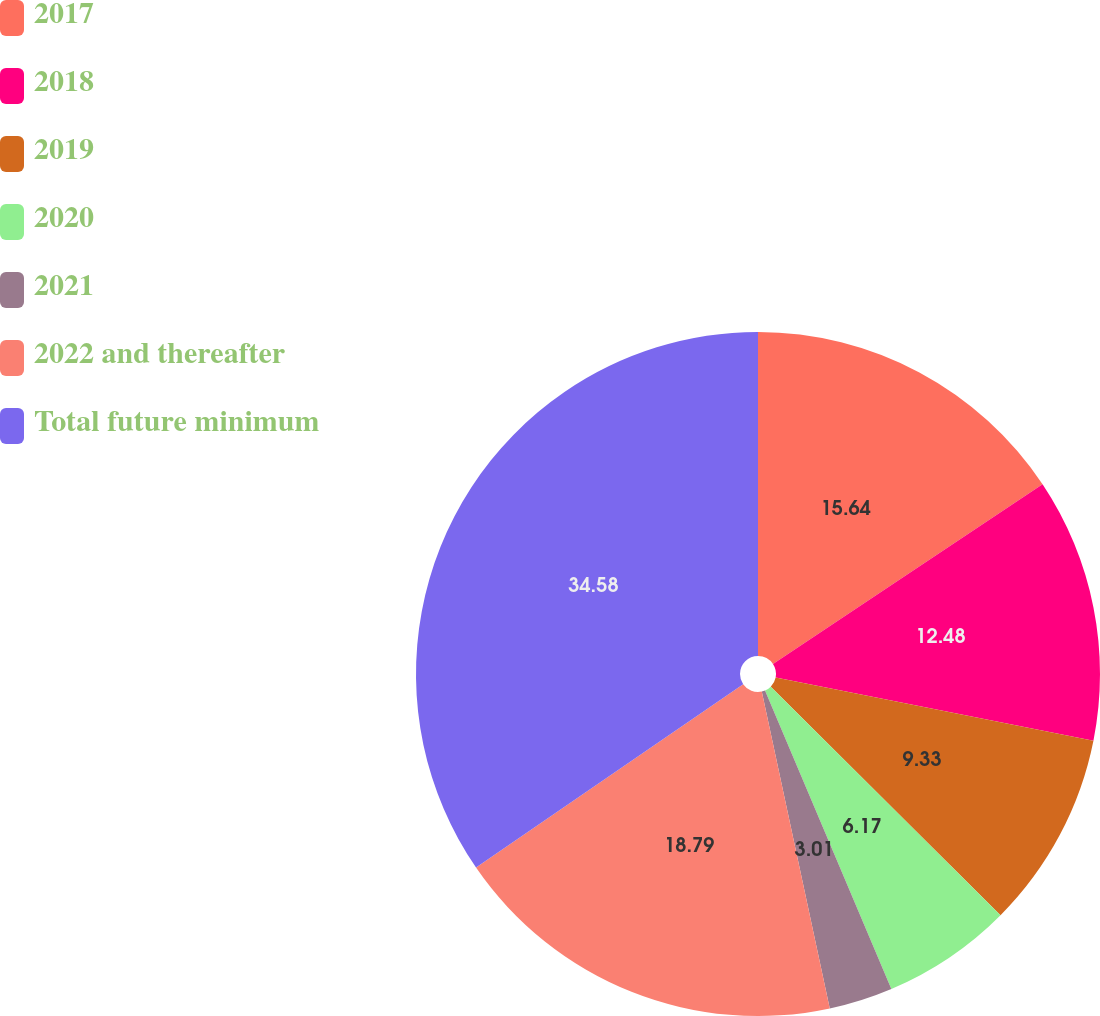<chart> <loc_0><loc_0><loc_500><loc_500><pie_chart><fcel>2017<fcel>2018<fcel>2019<fcel>2020<fcel>2021<fcel>2022 and thereafter<fcel>Total future minimum<nl><fcel>15.64%<fcel>12.48%<fcel>9.33%<fcel>6.17%<fcel>3.01%<fcel>18.79%<fcel>34.57%<nl></chart> 